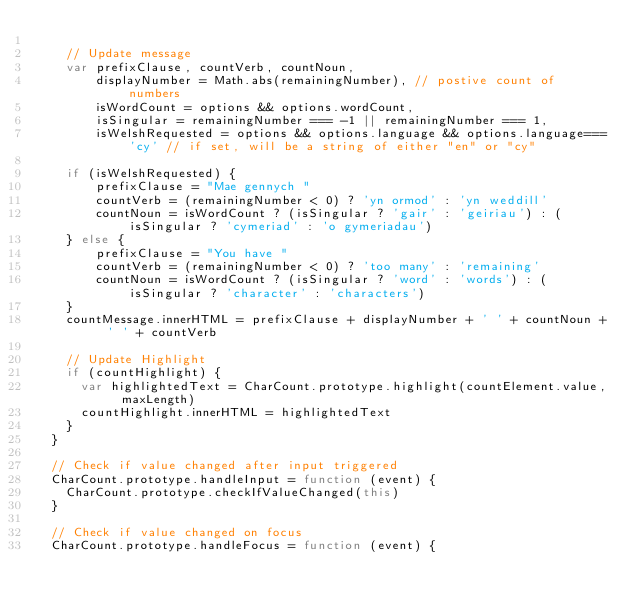<code> <loc_0><loc_0><loc_500><loc_500><_JavaScript_>
    // Update message
    var prefixClause, countVerb, countNoun,
        displayNumber = Math.abs(remainingNumber), // postive count of numbers
        isWordCount = options && options.wordCount,
        isSingular = remainingNumber === -1 || remainingNumber === 1,
        isWelshRequested = options && options.language && options.language==='cy' // if set, will be a string of either "en" or "cy"

    if (isWelshRequested) {
        prefixClause = "Mae gennych "
        countVerb = (remainingNumber < 0) ? 'yn ormod' : 'yn weddill'
        countNoun = isWordCount ? (isSingular ? 'gair' : 'geiriau') : (isSingular ? 'cymeriad' : 'o gymeriadau')
    } else {
        prefixClause = "You have "
        countVerb = (remainingNumber < 0) ? 'too many' : 'remaining'
        countNoun = isWordCount ? (isSingular ? 'word' : 'words') : (isSingular ? 'character' : 'characters')
    }
    countMessage.innerHTML = prefixClause + displayNumber + ' ' + countNoun + ' ' + countVerb

    // Update Highlight
    if (countHighlight) {
      var highlightedText = CharCount.prototype.highlight(countElement.value, maxLength)
      countHighlight.innerHTML = highlightedText
    }
  }

  // Check if value changed after input triggered
  CharCount.prototype.handleInput = function (event) {
    CharCount.prototype.checkIfValueChanged(this)
  }

  // Check if value changed on focus
  CharCount.prototype.handleFocus = function (event) {</code> 